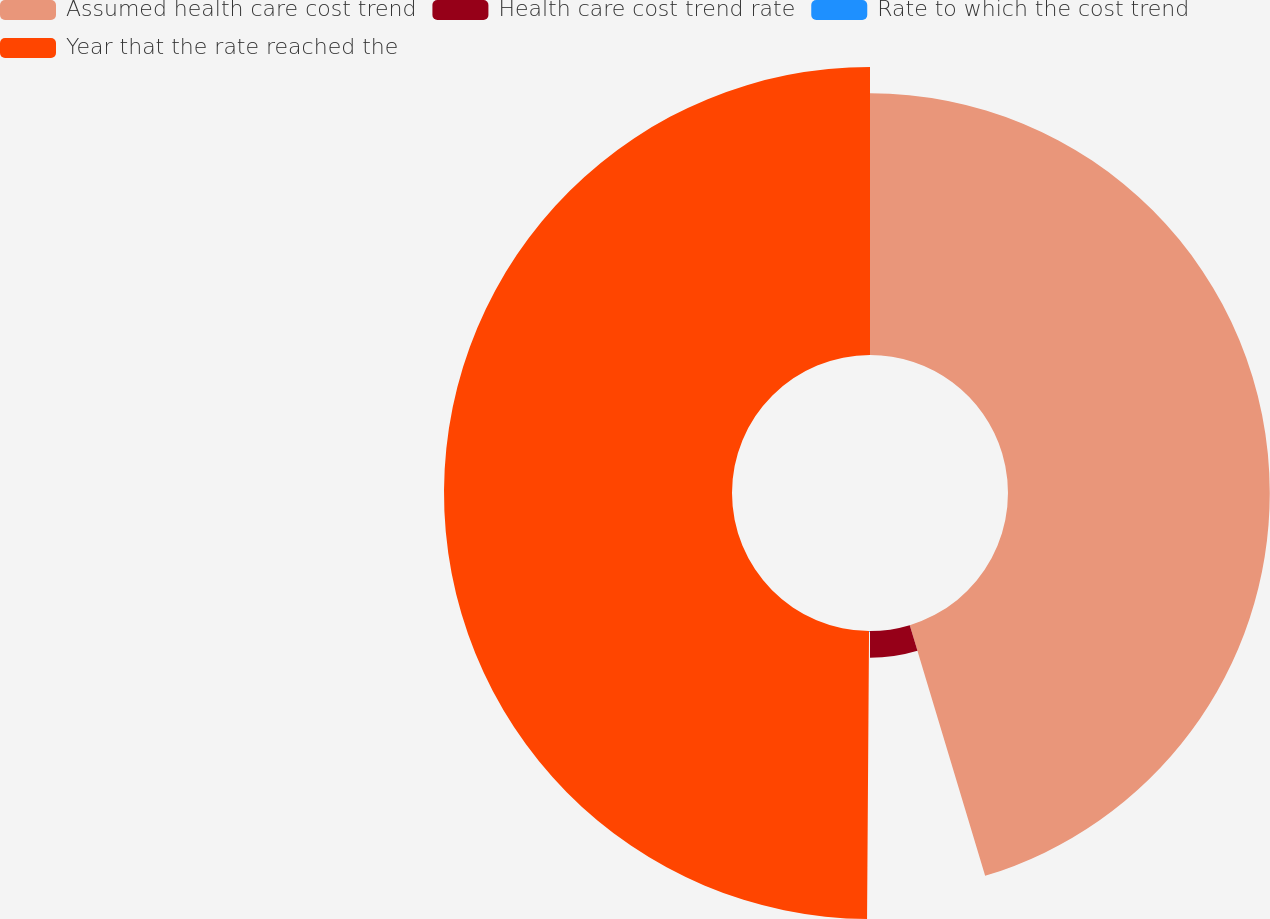<chart> <loc_0><loc_0><loc_500><loc_500><pie_chart><fcel>Assumed health care cost trend<fcel>Health care cost trend rate<fcel>Rate to which the cost trend<fcel>Year that the rate reached the<nl><fcel>45.35%<fcel>4.65%<fcel>0.11%<fcel>49.89%<nl></chart> 